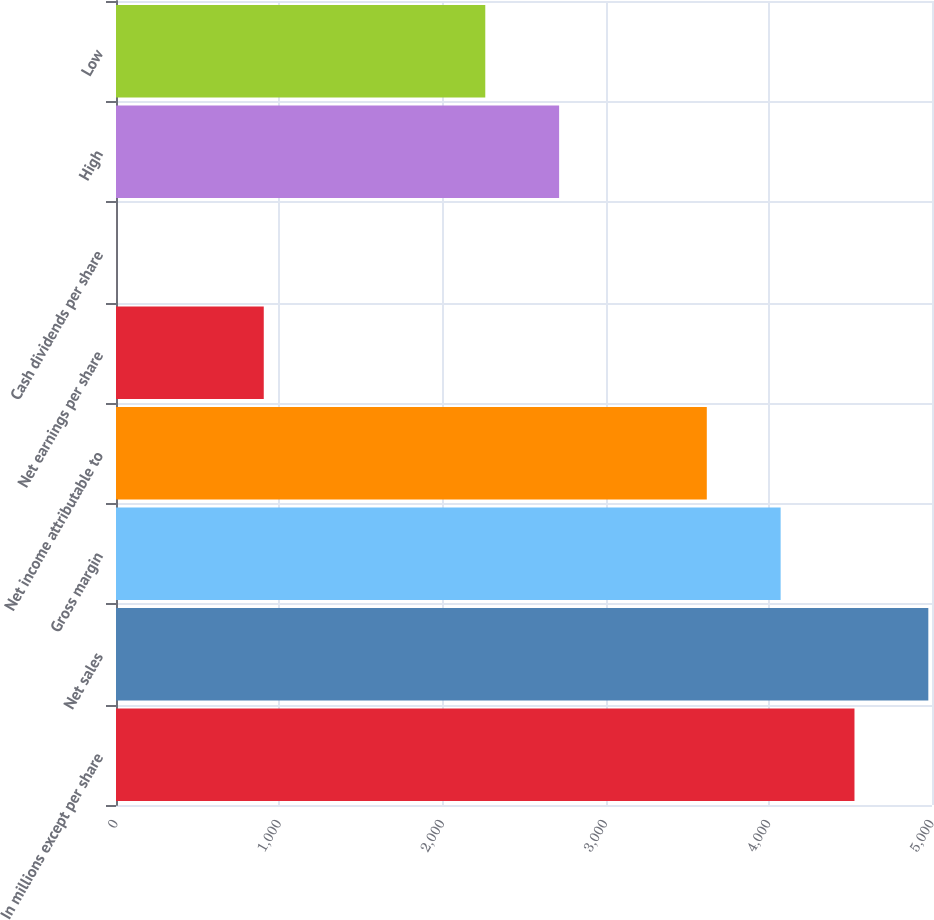<chart> <loc_0><loc_0><loc_500><loc_500><bar_chart><fcel>In millions except per share<fcel>Net sales<fcel>Gross margin<fcel>Net income attributable to<fcel>Net earnings per share<fcel>Cash dividends per share<fcel>High<fcel>Low<nl><fcel>4525<fcel>4977.45<fcel>4072.55<fcel>3620.1<fcel>905.4<fcel>0.5<fcel>2715.2<fcel>2262.75<nl></chart> 